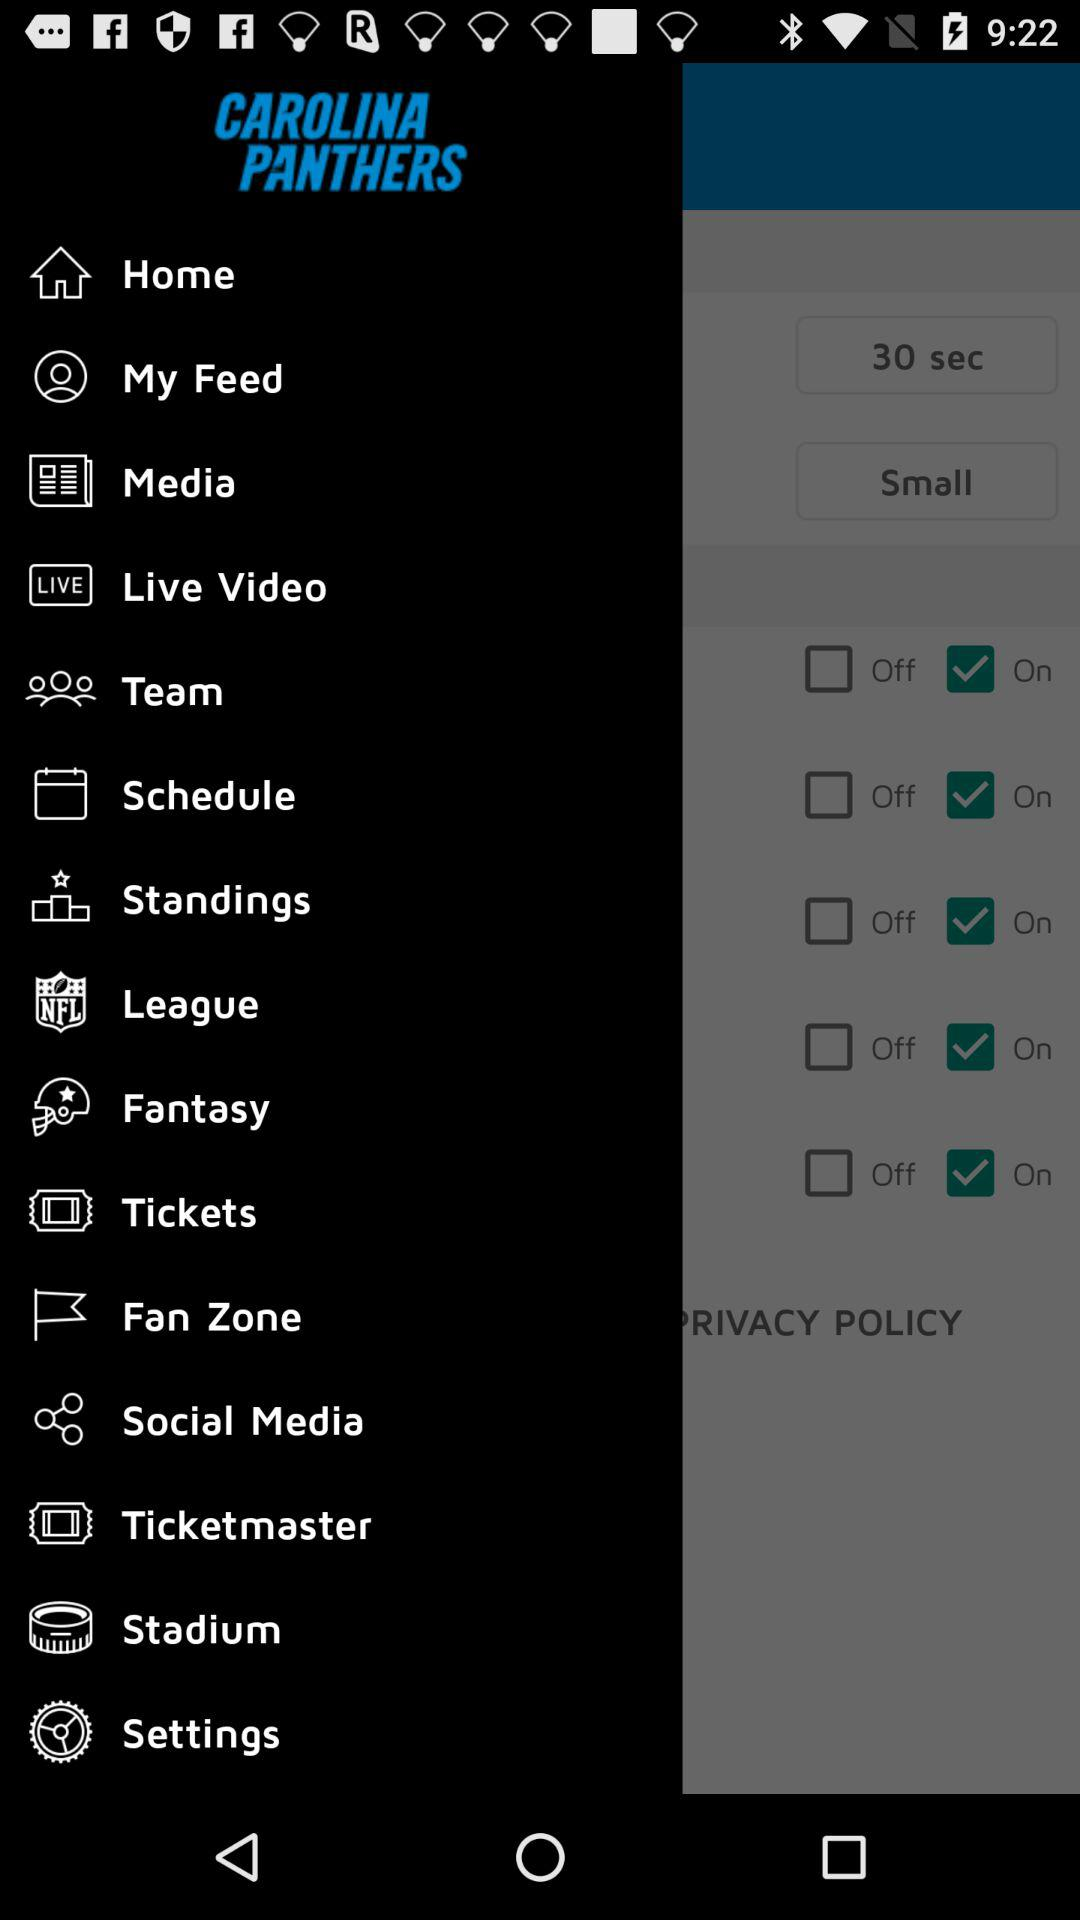What is the app name? The app name is "CAROLINA PANTHERS". 